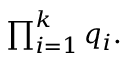<formula> <loc_0><loc_0><loc_500><loc_500>\prod _ { i = 1 } ^ { k } q _ { i } .</formula> 